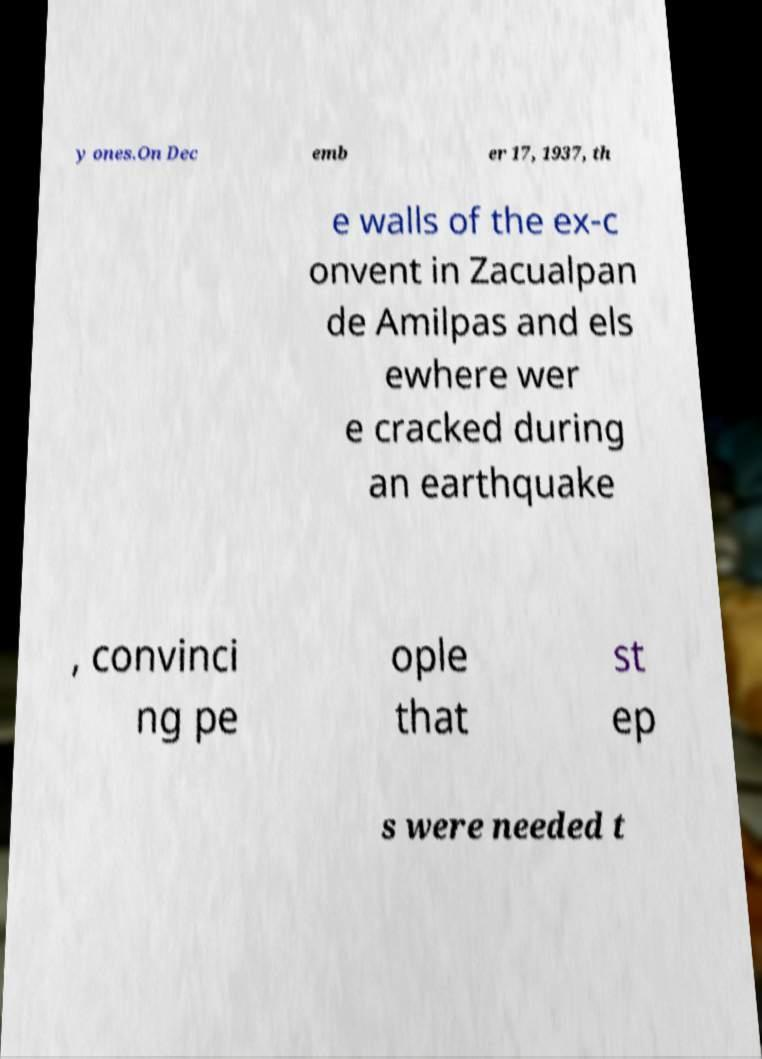Please read and relay the text visible in this image. What does it say? y ones.On Dec emb er 17, 1937, th e walls of the ex-c onvent in Zacualpan de Amilpas and els ewhere wer e cracked during an earthquake , convinci ng pe ople that st ep s were needed t 